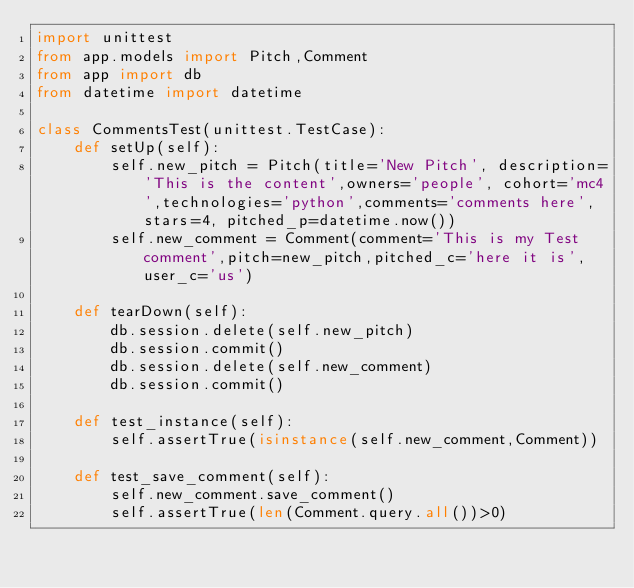<code> <loc_0><loc_0><loc_500><loc_500><_Python_>import unittest
from app.models import Pitch,Comment
from app import db
from datetime import datetime

class CommentsTest(unittest.TestCase):
    def setUp(self):
        self.new_pitch = Pitch(title='New Pitch', description='This is the content',owners='people', cohort='mc4',technologies='python',comments='comments here',stars=4, pitched_p=datetime.now())
        self.new_comment = Comment(comment='This is my Test comment',pitch=new_pitch,pitched_c='here it is',user_c='us')

    def tearDown(self):
        db.session.delete(self.new_pitch)
        db.session.commit()
        db.session.delete(self.new_comment)
        db.session.commit()

    def test_instance(self):
        self.assertTrue(isinstance(self.new_comment,Comment))

    def test_save_comment(self):
        self.new_comment.save_comment()
        self.assertTrue(len(Comment.query.all())>0)
</code> 